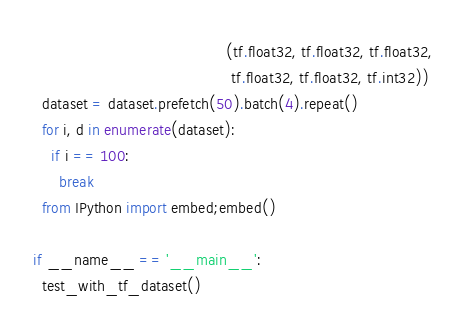Convert code to text. <code><loc_0><loc_0><loc_500><loc_500><_Python_>                                            (tf.float32, tf.float32, tf.float32,
                                             tf.float32, tf.float32, tf.int32))
  dataset = dataset.prefetch(50).batch(4).repeat()
  for i, d in enumerate(dataset):
    if i == 100:
      break
  from IPython import embed;embed()

if __name__ == '__main__':
  test_with_tf_dataset()
</code> 